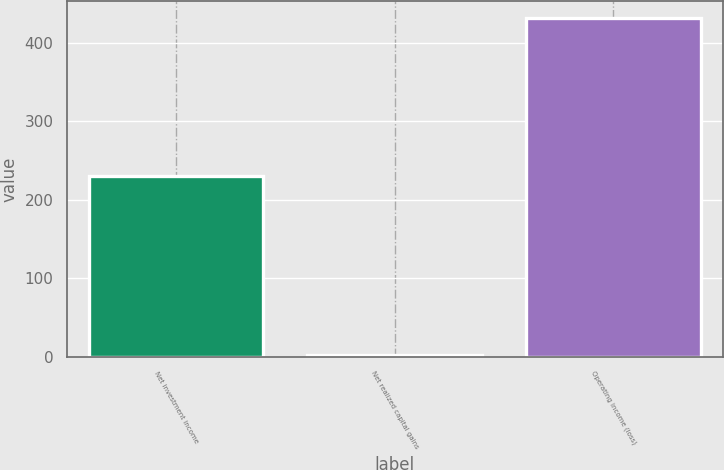Convert chart to OTSL. <chart><loc_0><loc_0><loc_500><loc_500><bar_chart><fcel>Net investment income<fcel>Net realized capital gains<fcel>Operating income (loss)<nl><fcel>231<fcel>2<fcel>432<nl></chart> 